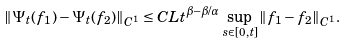Convert formula to latex. <formula><loc_0><loc_0><loc_500><loc_500>\| \Psi _ { t } ( f _ { 1 } ) - \Psi _ { t } ( f _ { 2 } ) \| _ { C ^ { 1 } } \leq C L t ^ { \beta - \beta / \alpha } \sup _ { s \in [ 0 , t ] } \| f _ { 1 } - f _ { 2 } \| _ { C ^ { 1 } } .</formula> 